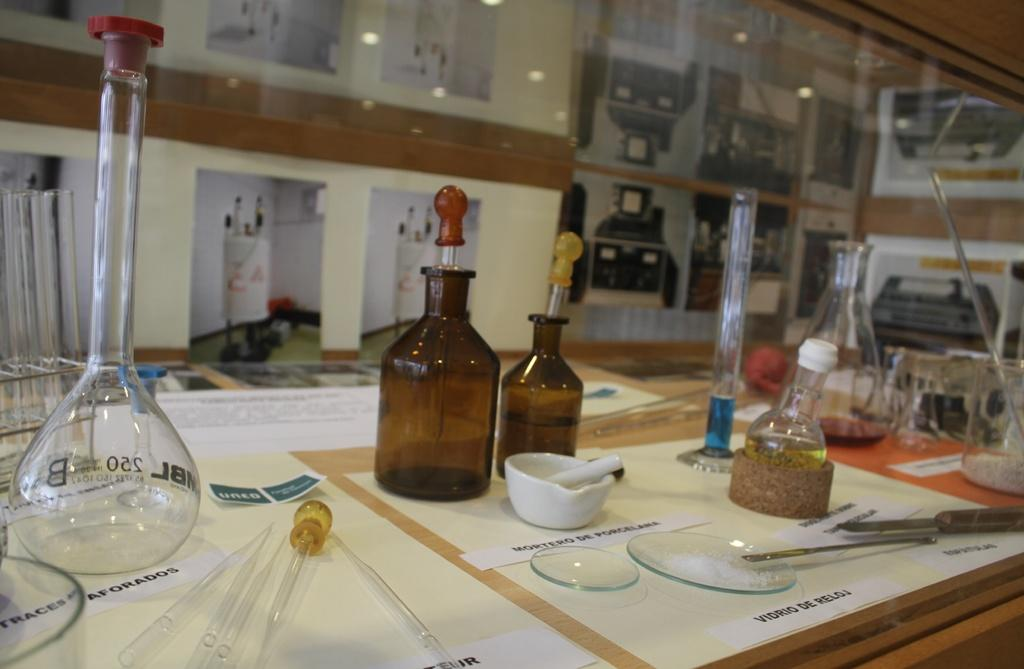What type of table is in the image? There is a wooden table in the image. What is placed on the wooden table? There is a glass flask on the table. Are there any other items related to the glass flask on the table? Yes, there are other chemical components on the table. How many laborers are working on the table in the image? There are no laborers present in the image; it features a wooden table with a glass flask and other chemical components. What type of worm can be seen crawling on the table in the image? There are no worms present in the image; it features a wooden table with a glass flask and other chemical components. 